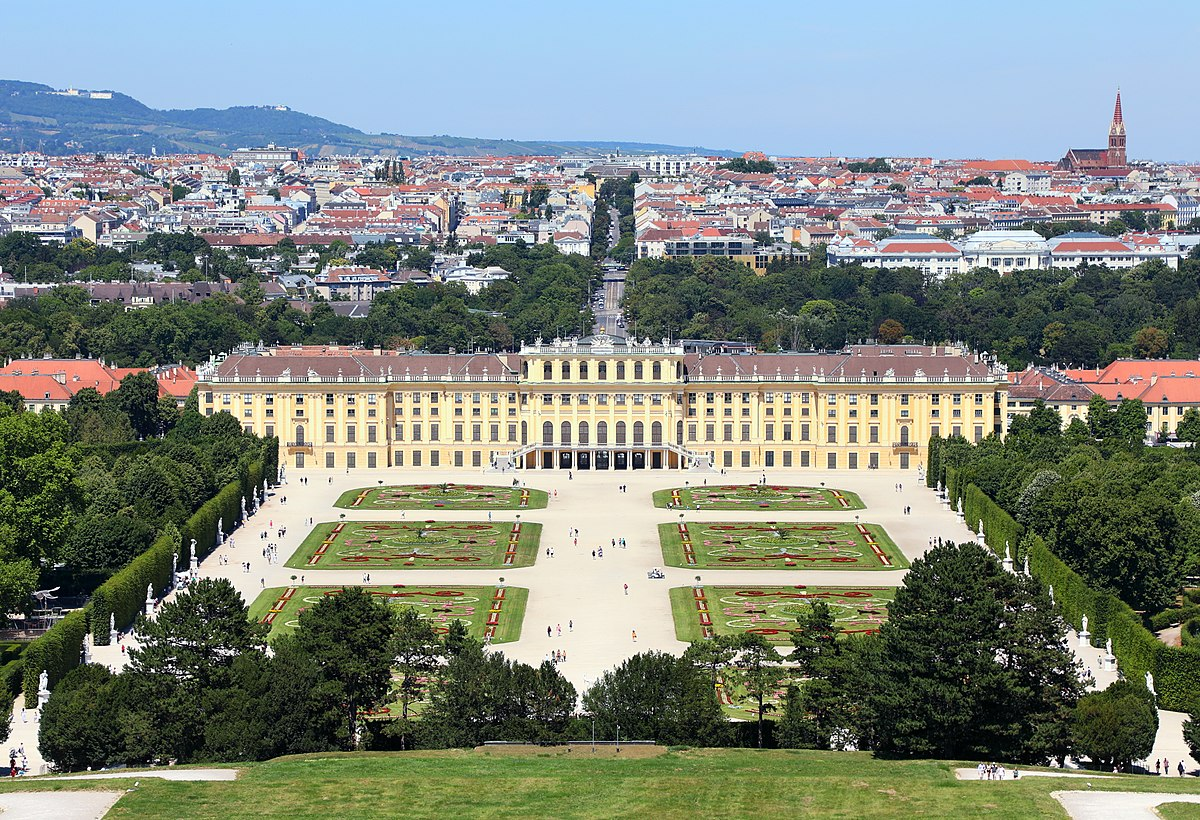What details can you provide about the garden's layout seen in the image? The gardens of Schonbrunn Palace, primarily designed in a French Baroque style, are a masterpiece of symmetry and precision. They are laid out in a series of terraces with precise geometrical patterns, reflecting the 18th-century ideals of order and beauty. The main elements include meticulously trimmed hedges, ornamental fountains, and statues based on Greek and Roman mythology. The presence of exotic flowers and plants adds to the variety and richness of the garden. Notably, the Great Parterre forms the central piece, lined with 32 sculptures that represent deities and virtues, leading the viewer's eyes towards the Neptune Fountain and the Gloriette, a hilltop structure offering panoramic views. 